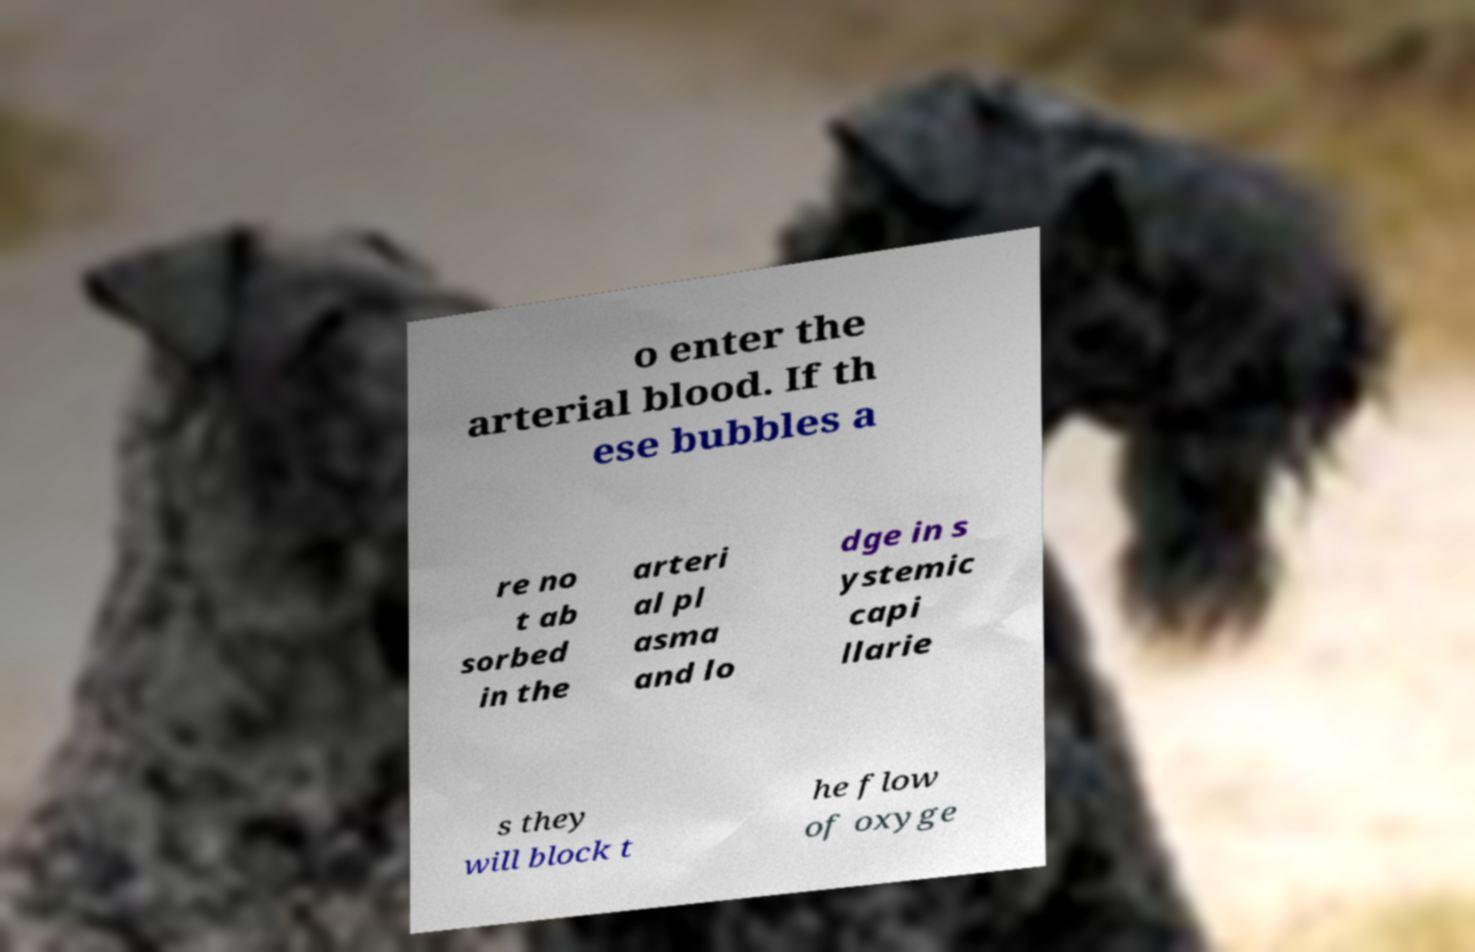For documentation purposes, I need the text within this image transcribed. Could you provide that? o enter the arterial blood. If th ese bubbles a re no t ab sorbed in the arteri al pl asma and lo dge in s ystemic capi llarie s they will block t he flow of oxyge 